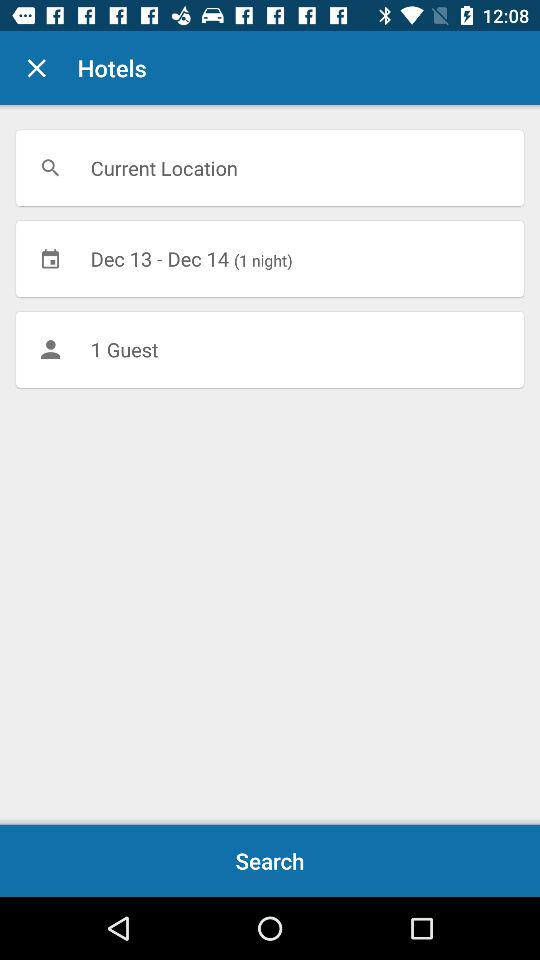How many guests are there?
Answer the question using a single word or phrase. 1 